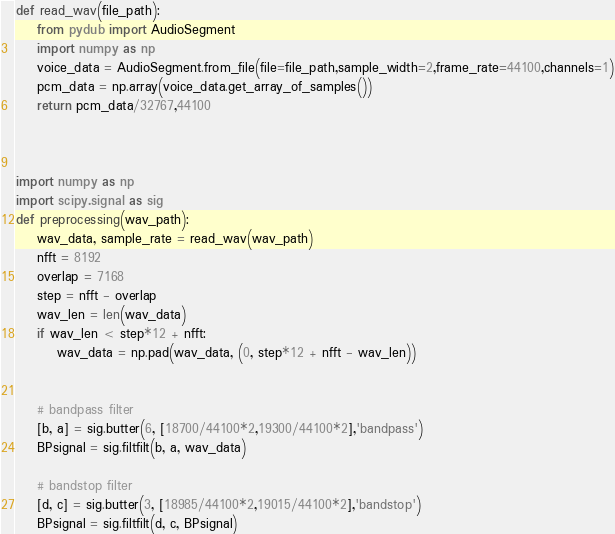<code> <loc_0><loc_0><loc_500><loc_500><_Python_>
def read_wav(file_path):
    from pydub import AudioSegment
    import numpy as np
    voice_data = AudioSegment.from_file(file=file_path,sample_width=2,frame_rate=44100,channels=1)
    pcm_data = np.array(voice_data.get_array_of_samples())
    return pcm_data/32767,44100



import numpy as np
import scipy.signal as sig
def preprocessing(wav_path):
    wav_data, sample_rate = read_wav(wav_path)
    nfft = 8192
    overlap = 7168
    step = nfft - overlap
    wav_len = len(wav_data)
    if wav_len < step*12 + nfft:
        wav_data = np.pad(wav_data, (0, step*12 + nfft - wav_len))


    # bandpass filter
    [b, a] = sig.butter(6, [18700/44100*2,19300/44100*2],'bandpass')
    BPsignal = sig.filtfilt(b, a, wav_data)

    # bandstop filter
    [d, c] = sig.butter(3, [18985/44100*2,19015/44100*2],'bandstop')
    BPsignal = sig.filtfilt(d, c, BPsignal)</code> 